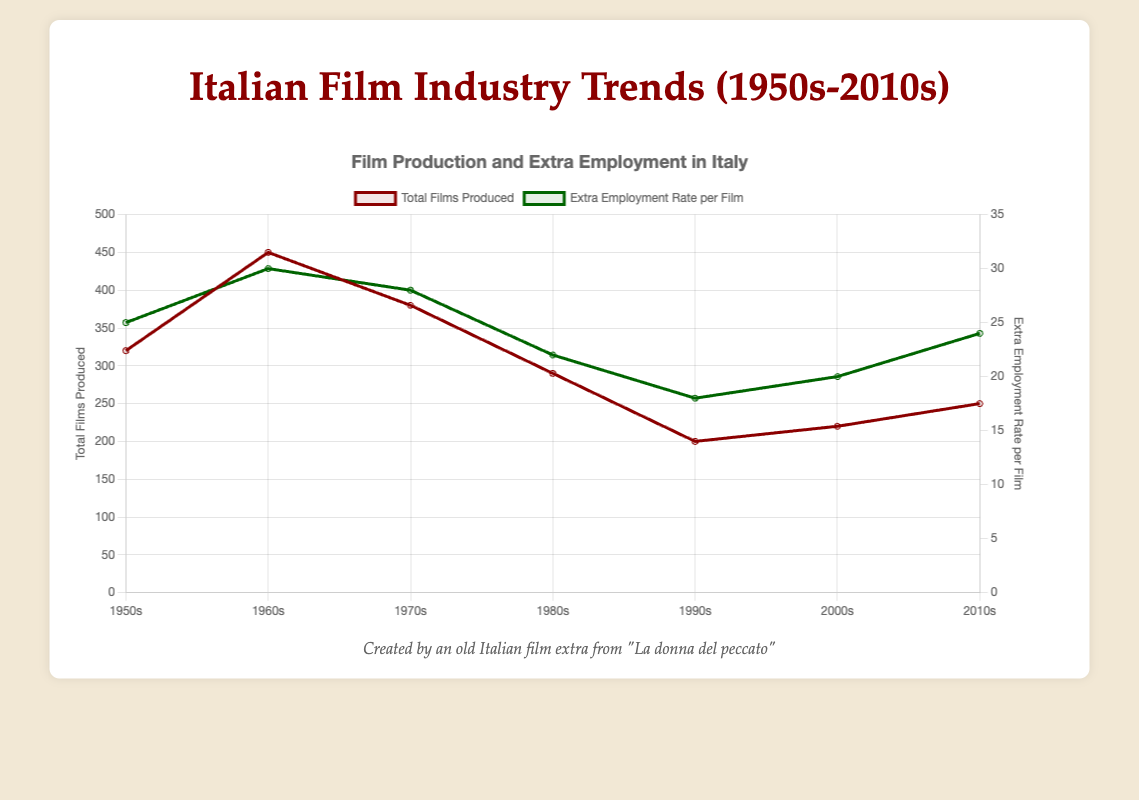Which decade had the highest number of films produced? To find the decade with the highest number of films produced, look at the "Total Films Produced" line and identify the peak. The peak appears in the 1960s.
Answer: 1960s What was the extra employment rate per film in the 1980s? To determine the extra employment rate per film in the 1980s, locate the point on the "Extra Employment Rate per Film" line corresponding to the 1980s. The value indicated is 22.
Answer: 22 Is the trend of total films produced generally increasing or decreasing from the 1950s to 2010s? Observe the overall direction of the "Total Films Produced" line from the 1950s to 2010s. The line shows an initial increase peaking in the 1960s and then generally decreasing afterward.
Answer: Decreasing What is the difference between the extra employment rate per film in the 1960s compared to the 1990s? Subtract the extra employment rate per film in the 1990s (18) from that of the 1960s (30). The calculation is 30 - 18 = 12.
Answer: 12 How many more films were produced in the 1970s than in the 2000s? Subtract the total films produced in the 2000s (220) from the total films produced in the 1970s (380). The calculation is 380 - 220 = 160.
Answer: 160 Which decade witnessed the lowest extra employment rate per film? Examine the "Extra Employment Rate per Film" line to find the lowest point. The 1990s have the lowest value of 18.
Answer: 1990s Between which two decades did the extra employment rate per film see the greatest increase? Calculate the differences between sequential decades for the "Extra Employment Rate per Film" values. The increase from the 1950s (25) to the 1960s (30) is the largest, with a change of 5.
Answer: 1950s to 1960s What was the combined total of films produced in the 1980s and 2010s? Add the total films produced in the 1980s (290) to those in the 2010s (250). The calculation is 290 + 250 = 540.
Answer: 540 Which decade had a greater extra employment rate per film, the 2000s or the 2010s? Compare the values of the extra employment rate per film for the 2000s (20) and the 2010s (24). The 2010s had a higher rate.
Answer: 2010s How did the total films produced in the 1990s compare to the 1950s? Compare the total films produced in the 1990s (200) with that of the 1950s (320). The 1990s produced fewer films by a difference of 120 films (320 - 200).
Answer: Fewer (by 120) 